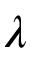Convert formula to latex. <formula><loc_0><loc_0><loc_500><loc_500>\lambda</formula> 